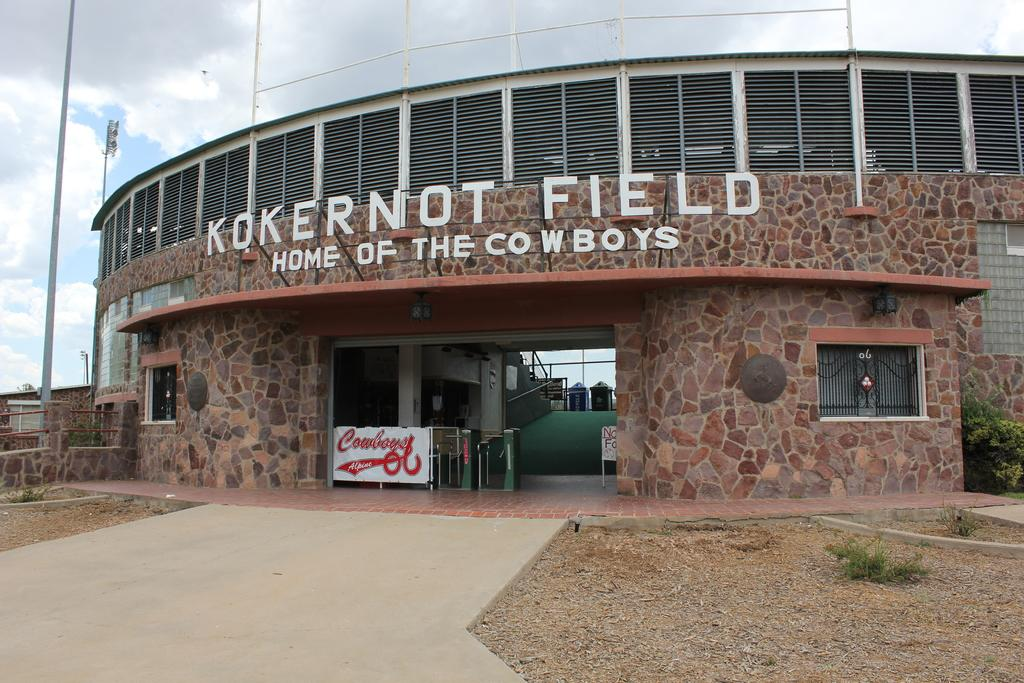What type of structure is present in the image? There is a building in the image. What is attached to the building? The building has a hoarding and a notice board. What can be seen near the building? There are plants beside the building. What other objects are visible in the image? There are poles and metal rods in the image. Are there any other types of structures in the image? Yes, there is a house in the image. What is the chance of the wound healing quickly in the image? There is no mention of a wound in the image, so it is not possible to determine the chance of it healing quickly. 